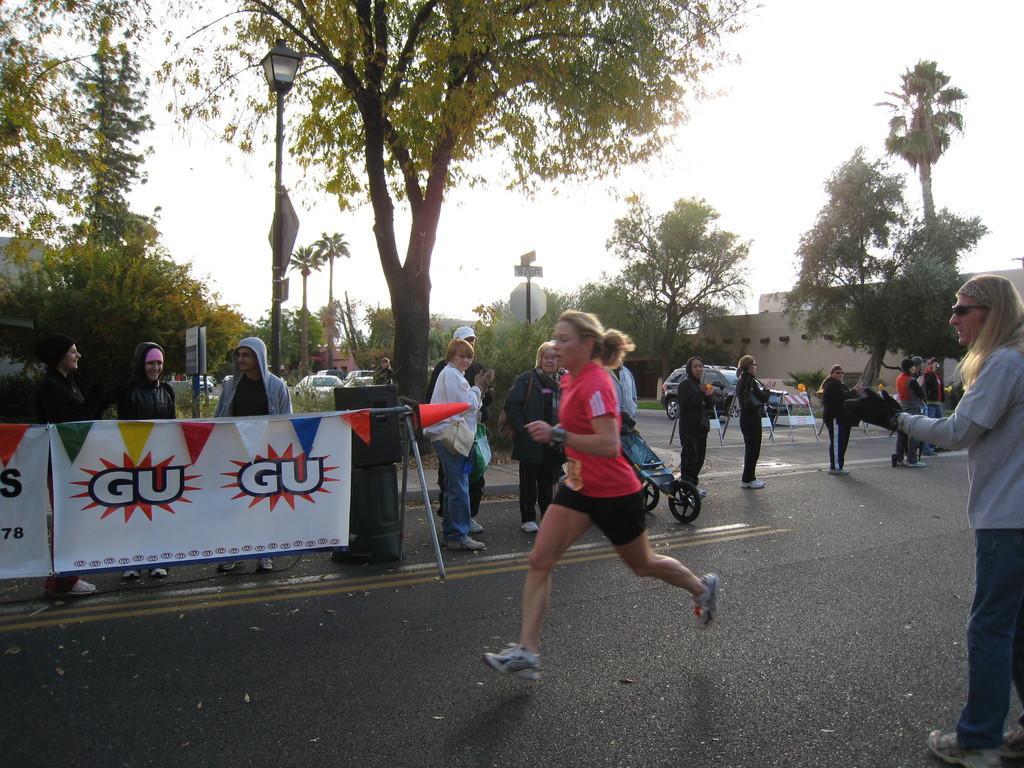Could you give a brief overview of what you see in this image? In this image I can see a road in the front and on it I can see number of people. On the right side of the image I can see two white colour boards, few paper flags and on these boards I can see something is written. In the background I can see number of trees, few poles, few boards, a street light, few buildings, number of vehicles, three barricades on the road and the sky. 